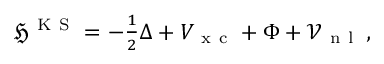Convert formula to latex. <formula><loc_0><loc_0><loc_500><loc_500>\begin{array} { r } { \mathfrak { H } ^ { K S } = - \frac { 1 } { 2 } \Delta + V _ { x c } + \Phi + \mathcal { V } _ { n l } \, , } \end{array}</formula> 